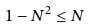<formula> <loc_0><loc_0><loc_500><loc_500>1 - N ^ { 2 } \leq N</formula> 